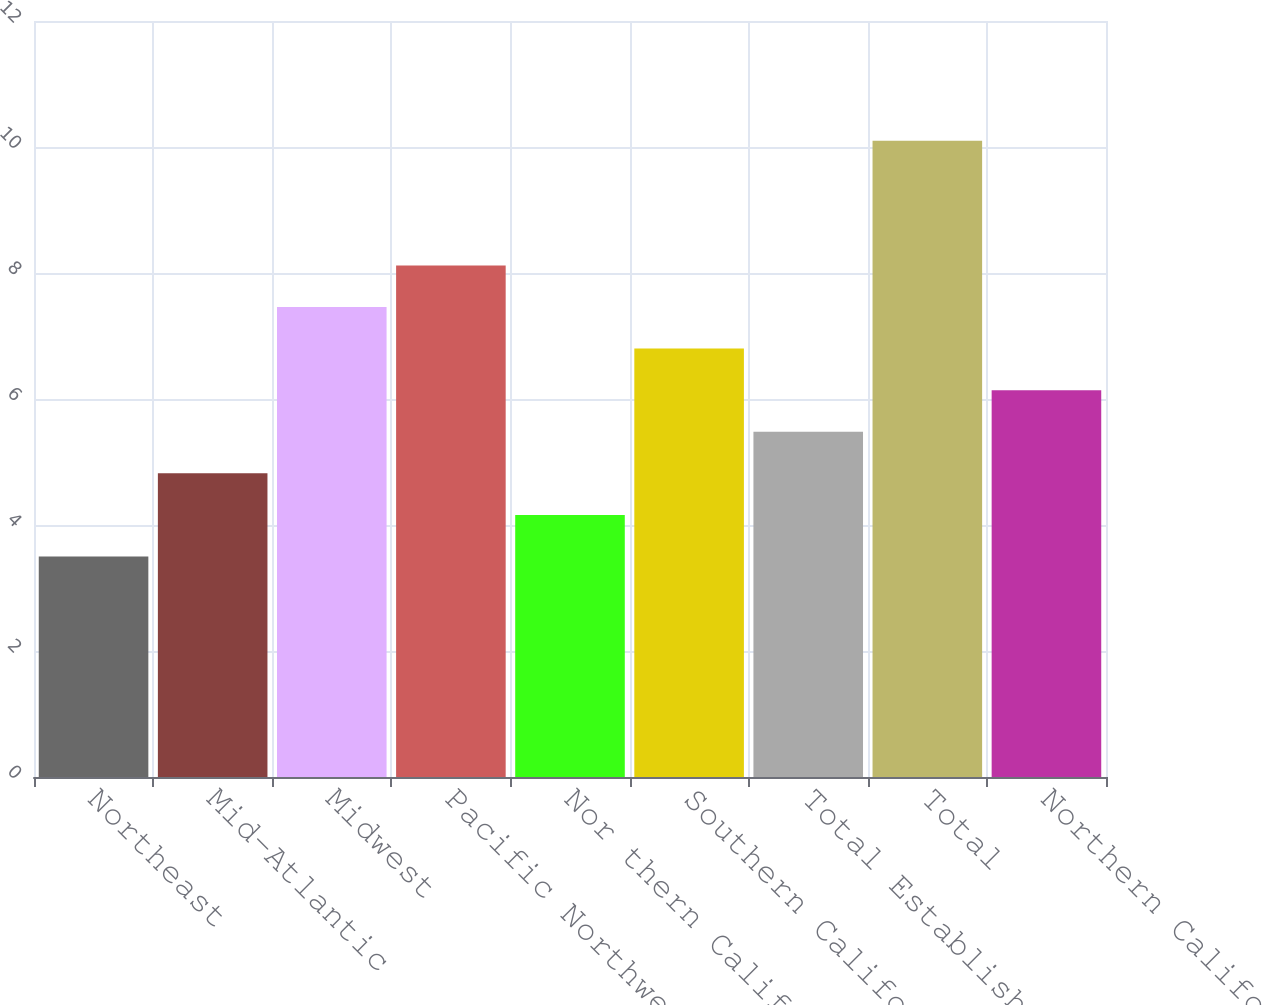Convert chart. <chart><loc_0><loc_0><loc_500><loc_500><bar_chart><fcel>Northeast<fcel>Mid-Atlantic<fcel>Midwest<fcel>Pacific Northwest<fcel>Nor thern California<fcel>Southern California<fcel>Total Established<fcel>Total<fcel>Northern California<nl><fcel>3.5<fcel>4.82<fcel>7.46<fcel>8.12<fcel>4.16<fcel>6.8<fcel>5.48<fcel>10.1<fcel>6.14<nl></chart> 